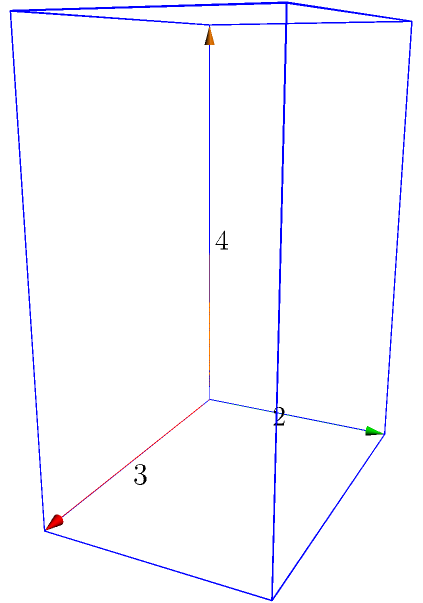As a data scientist working with MongoDB, you're designing a 3D object storage system. You need to calculate the surface area of a rectangular prism representing a data storage unit. Given the dimensions of the prism as length = 3 units, width = 2 units, and height = 4 units, what is the total surface area of this rectangular prism? To calculate the surface area of a rectangular prism, we need to follow these steps:

1. Identify the formula for surface area of a rectangular prism:
   Surface Area = 2(lw + lh + wh), where l = length, w = width, and h = height

2. Substitute the given values:
   l = 3, w = 2, h = 4

3. Calculate each part of the formula:
   lw = 3 × 2 = 6
   lh = 3 × 4 = 12
   wh = 2 × 4 = 8

4. Sum up the parts:
   lw + lh + wh = 6 + 12 + 8 = 26

5. Multiply by 2:
   2(lw + lh + wh) = 2 × 26 = 52

Therefore, the total surface area of the rectangular prism is 52 square units.
Answer: $52$ square units 